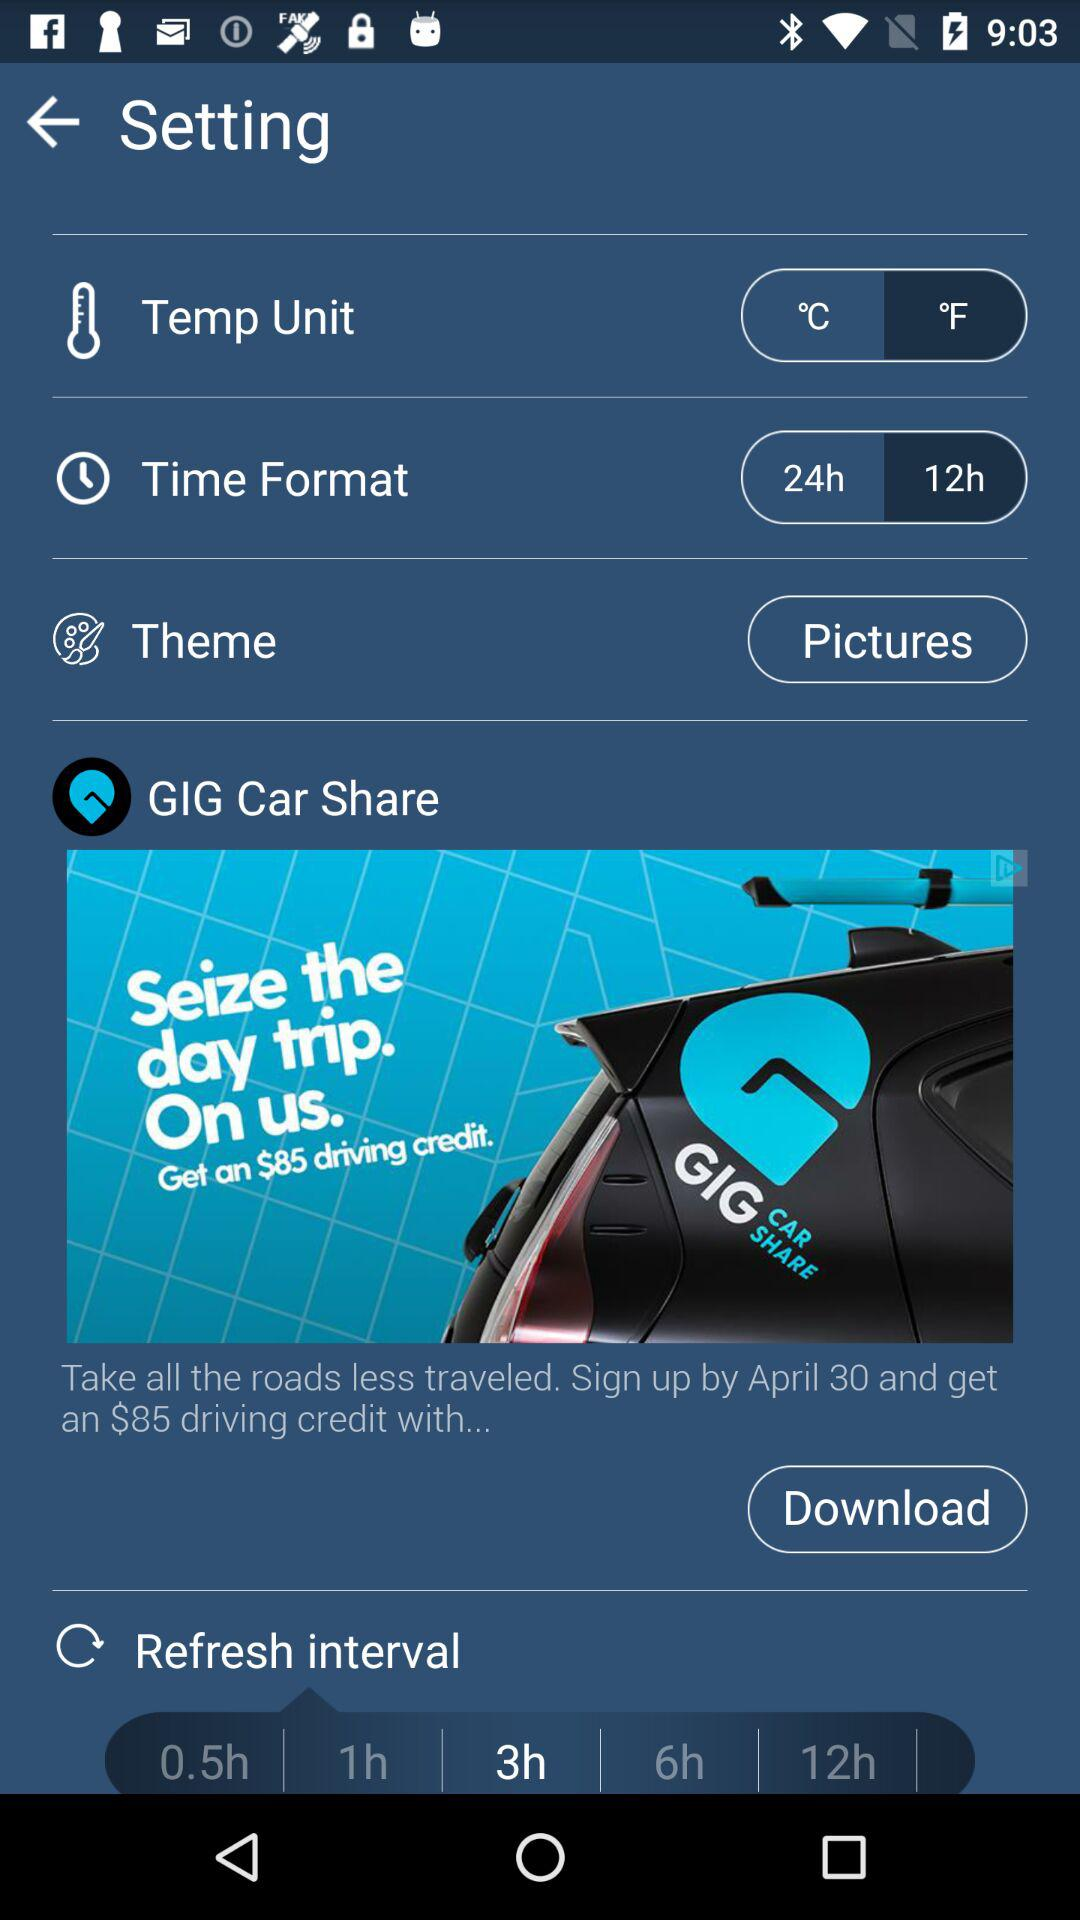What is the selected time format? The selected time format is 12 hours. 